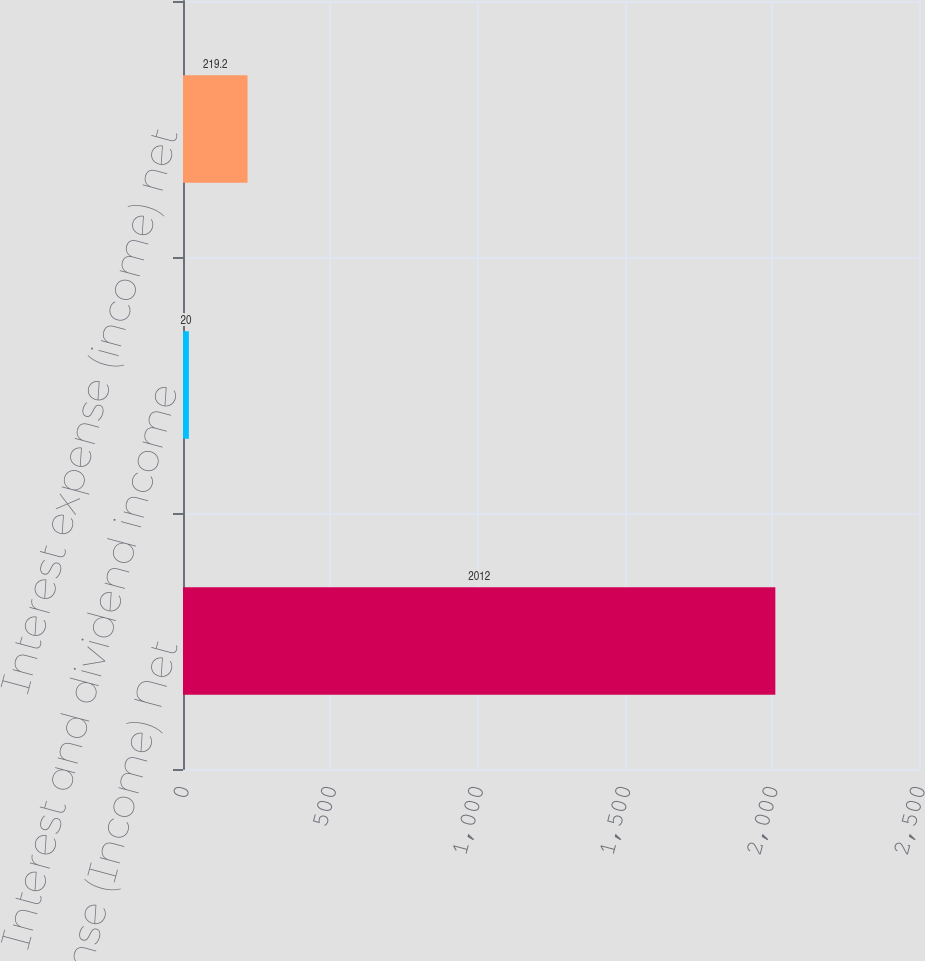Convert chart. <chart><loc_0><loc_0><loc_500><loc_500><bar_chart><fcel>Interest Expense (Income) Net<fcel>Interest and dividend income<fcel>Interest expense (income) net<nl><fcel>2012<fcel>20<fcel>219.2<nl></chart> 